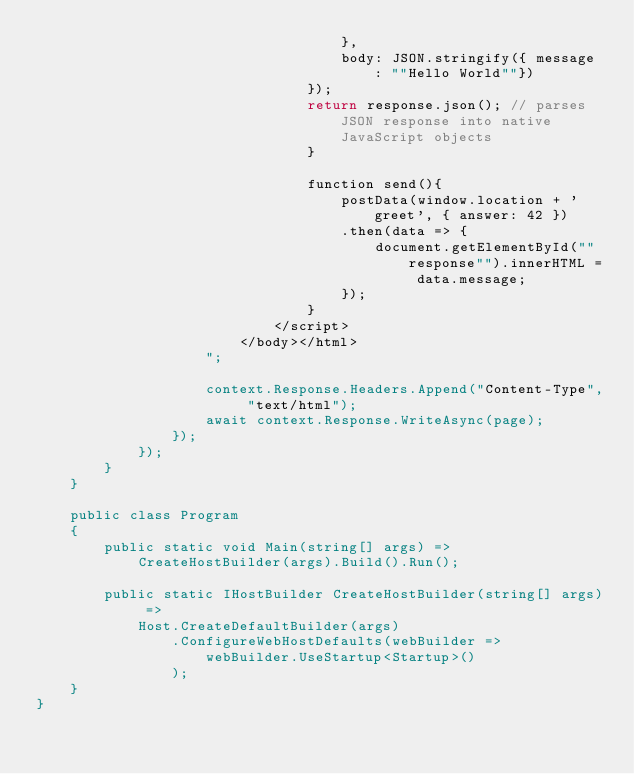<code> <loc_0><loc_0><loc_500><loc_500><_C#_>                                    },
                                    body: JSON.stringify({ message : ""Hello World""}) 
                                });
                                return response.json(); // parses JSON response into native JavaScript objects
                                }
                                
                                function send(){
                                    postData(window.location + 'greet', { answer: 42 })
                                    .then(data => {
                                        document.getElementById(""response"").innerHTML = data.message;
                                    });
                                }
                            </script>
                        </body></html>
                    ";

                    context.Response.Headers.Append("Content-Type", "text/html");
                    await context.Response.WriteAsync(page);
                });
            });
        }
    }

    public class Program
    {
        public static void Main(string[] args) =>
            CreateHostBuilder(args).Build().Run();

        public static IHostBuilder CreateHostBuilder(string[] args) =>
            Host.CreateDefaultBuilder(args)
                .ConfigureWebHostDefaults(webBuilder =>
                    webBuilder.UseStartup<Startup>()
                );
    }
}</code> 